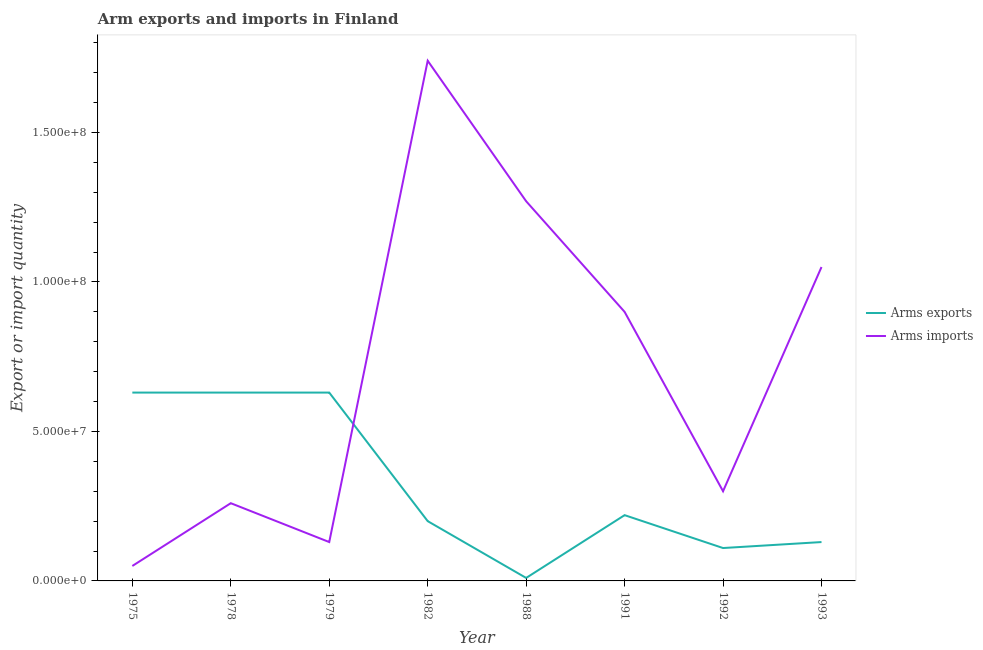How many different coloured lines are there?
Your answer should be very brief. 2. Does the line corresponding to arms exports intersect with the line corresponding to arms imports?
Make the answer very short. Yes. Is the number of lines equal to the number of legend labels?
Make the answer very short. Yes. What is the arms imports in 1979?
Your answer should be very brief. 1.30e+07. Across all years, what is the maximum arms imports?
Ensure brevity in your answer.  1.74e+08. Across all years, what is the minimum arms imports?
Provide a succinct answer. 5.00e+06. In which year was the arms imports maximum?
Keep it short and to the point. 1982. In which year was the arms exports minimum?
Make the answer very short. 1988. What is the total arms imports in the graph?
Keep it short and to the point. 5.70e+08. What is the difference between the arms imports in 1975 and that in 1978?
Offer a terse response. -2.10e+07. What is the difference between the arms exports in 1988 and the arms imports in 1978?
Provide a succinct answer. -2.50e+07. What is the average arms imports per year?
Your answer should be compact. 7.12e+07. In the year 1988, what is the difference between the arms exports and arms imports?
Provide a succinct answer. -1.26e+08. In how many years, is the arms imports greater than 70000000?
Keep it short and to the point. 4. What is the difference between the highest and the second highest arms imports?
Provide a short and direct response. 4.70e+07. What is the difference between the highest and the lowest arms imports?
Provide a short and direct response. 1.69e+08. In how many years, is the arms imports greater than the average arms imports taken over all years?
Provide a succinct answer. 4. Is the sum of the arms exports in 1979 and 1988 greater than the maximum arms imports across all years?
Provide a succinct answer. No. Does the arms imports monotonically increase over the years?
Keep it short and to the point. No. Is the arms exports strictly greater than the arms imports over the years?
Provide a succinct answer. No. Is the arms exports strictly less than the arms imports over the years?
Offer a terse response. No. How many lines are there?
Offer a very short reply. 2. How many years are there in the graph?
Offer a very short reply. 8. What is the difference between two consecutive major ticks on the Y-axis?
Your answer should be very brief. 5.00e+07. Are the values on the major ticks of Y-axis written in scientific E-notation?
Offer a very short reply. Yes. Does the graph contain grids?
Provide a short and direct response. No. How many legend labels are there?
Ensure brevity in your answer.  2. How are the legend labels stacked?
Offer a very short reply. Vertical. What is the title of the graph?
Offer a terse response. Arm exports and imports in Finland. Does "Pregnant women" appear as one of the legend labels in the graph?
Make the answer very short. No. What is the label or title of the X-axis?
Make the answer very short. Year. What is the label or title of the Y-axis?
Give a very brief answer. Export or import quantity. What is the Export or import quantity in Arms exports in 1975?
Provide a short and direct response. 6.30e+07. What is the Export or import quantity in Arms imports in 1975?
Make the answer very short. 5.00e+06. What is the Export or import quantity in Arms exports in 1978?
Provide a short and direct response. 6.30e+07. What is the Export or import quantity of Arms imports in 1978?
Offer a terse response. 2.60e+07. What is the Export or import quantity of Arms exports in 1979?
Offer a terse response. 6.30e+07. What is the Export or import quantity of Arms imports in 1979?
Offer a terse response. 1.30e+07. What is the Export or import quantity of Arms imports in 1982?
Ensure brevity in your answer.  1.74e+08. What is the Export or import quantity of Arms exports in 1988?
Make the answer very short. 1.00e+06. What is the Export or import quantity of Arms imports in 1988?
Provide a short and direct response. 1.27e+08. What is the Export or import quantity in Arms exports in 1991?
Provide a short and direct response. 2.20e+07. What is the Export or import quantity in Arms imports in 1991?
Give a very brief answer. 9.00e+07. What is the Export or import quantity of Arms exports in 1992?
Keep it short and to the point. 1.10e+07. What is the Export or import quantity of Arms imports in 1992?
Your answer should be compact. 3.00e+07. What is the Export or import quantity in Arms exports in 1993?
Your response must be concise. 1.30e+07. What is the Export or import quantity of Arms imports in 1993?
Your answer should be compact. 1.05e+08. Across all years, what is the maximum Export or import quantity in Arms exports?
Your answer should be compact. 6.30e+07. Across all years, what is the maximum Export or import quantity in Arms imports?
Offer a terse response. 1.74e+08. Across all years, what is the minimum Export or import quantity in Arms exports?
Give a very brief answer. 1.00e+06. Across all years, what is the minimum Export or import quantity in Arms imports?
Your answer should be compact. 5.00e+06. What is the total Export or import quantity in Arms exports in the graph?
Your answer should be very brief. 2.56e+08. What is the total Export or import quantity in Arms imports in the graph?
Give a very brief answer. 5.70e+08. What is the difference between the Export or import quantity of Arms exports in 1975 and that in 1978?
Ensure brevity in your answer.  0. What is the difference between the Export or import quantity of Arms imports in 1975 and that in 1978?
Offer a terse response. -2.10e+07. What is the difference between the Export or import quantity in Arms imports in 1975 and that in 1979?
Provide a succinct answer. -8.00e+06. What is the difference between the Export or import quantity in Arms exports in 1975 and that in 1982?
Give a very brief answer. 4.30e+07. What is the difference between the Export or import quantity in Arms imports in 1975 and that in 1982?
Keep it short and to the point. -1.69e+08. What is the difference between the Export or import quantity in Arms exports in 1975 and that in 1988?
Ensure brevity in your answer.  6.20e+07. What is the difference between the Export or import quantity in Arms imports in 1975 and that in 1988?
Ensure brevity in your answer.  -1.22e+08. What is the difference between the Export or import quantity in Arms exports in 1975 and that in 1991?
Give a very brief answer. 4.10e+07. What is the difference between the Export or import quantity in Arms imports in 1975 and that in 1991?
Ensure brevity in your answer.  -8.50e+07. What is the difference between the Export or import quantity of Arms exports in 1975 and that in 1992?
Keep it short and to the point. 5.20e+07. What is the difference between the Export or import quantity of Arms imports in 1975 and that in 1992?
Make the answer very short. -2.50e+07. What is the difference between the Export or import quantity in Arms exports in 1975 and that in 1993?
Keep it short and to the point. 5.00e+07. What is the difference between the Export or import quantity in Arms imports in 1975 and that in 1993?
Keep it short and to the point. -1.00e+08. What is the difference between the Export or import quantity of Arms exports in 1978 and that in 1979?
Make the answer very short. 0. What is the difference between the Export or import quantity of Arms imports in 1978 and that in 1979?
Make the answer very short. 1.30e+07. What is the difference between the Export or import quantity in Arms exports in 1978 and that in 1982?
Your answer should be compact. 4.30e+07. What is the difference between the Export or import quantity in Arms imports in 1978 and that in 1982?
Offer a very short reply. -1.48e+08. What is the difference between the Export or import quantity of Arms exports in 1978 and that in 1988?
Your answer should be very brief. 6.20e+07. What is the difference between the Export or import quantity in Arms imports in 1978 and that in 1988?
Keep it short and to the point. -1.01e+08. What is the difference between the Export or import quantity in Arms exports in 1978 and that in 1991?
Make the answer very short. 4.10e+07. What is the difference between the Export or import quantity of Arms imports in 1978 and that in 1991?
Provide a succinct answer. -6.40e+07. What is the difference between the Export or import quantity of Arms exports in 1978 and that in 1992?
Make the answer very short. 5.20e+07. What is the difference between the Export or import quantity in Arms imports in 1978 and that in 1993?
Your response must be concise. -7.90e+07. What is the difference between the Export or import quantity in Arms exports in 1979 and that in 1982?
Provide a short and direct response. 4.30e+07. What is the difference between the Export or import quantity of Arms imports in 1979 and that in 1982?
Ensure brevity in your answer.  -1.61e+08. What is the difference between the Export or import quantity of Arms exports in 1979 and that in 1988?
Keep it short and to the point. 6.20e+07. What is the difference between the Export or import quantity of Arms imports in 1979 and that in 1988?
Offer a terse response. -1.14e+08. What is the difference between the Export or import quantity of Arms exports in 1979 and that in 1991?
Provide a short and direct response. 4.10e+07. What is the difference between the Export or import quantity of Arms imports in 1979 and that in 1991?
Keep it short and to the point. -7.70e+07. What is the difference between the Export or import quantity of Arms exports in 1979 and that in 1992?
Provide a succinct answer. 5.20e+07. What is the difference between the Export or import quantity in Arms imports in 1979 and that in 1992?
Provide a succinct answer. -1.70e+07. What is the difference between the Export or import quantity of Arms imports in 1979 and that in 1993?
Make the answer very short. -9.20e+07. What is the difference between the Export or import quantity of Arms exports in 1982 and that in 1988?
Ensure brevity in your answer.  1.90e+07. What is the difference between the Export or import quantity of Arms imports in 1982 and that in 1988?
Make the answer very short. 4.70e+07. What is the difference between the Export or import quantity of Arms imports in 1982 and that in 1991?
Keep it short and to the point. 8.40e+07. What is the difference between the Export or import quantity of Arms exports in 1982 and that in 1992?
Provide a succinct answer. 9.00e+06. What is the difference between the Export or import quantity of Arms imports in 1982 and that in 1992?
Give a very brief answer. 1.44e+08. What is the difference between the Export or import quantity in Arms imports in 1982 and that in 1993?
Ensure brevity in your answer.  6.90e+07. What is the difference between the Export or import quantity in Arms exports in 1988 and that in 1991?
Keep it short and to the point. -2.10e+07. What is the difference between the Export or import quantity of Arms imports in 1988 and that in 1991?
Provide a short and direct response. 3.70e+07. What is the difference between the Export or import quantity of Arms exports in 1988 and that in 1992?
Ensure brevity in your answer.  -1.00e+07. What is the difference between the Export or import quantity in Arms imports in 1988 and that in 1992?
Offer a very short reply. 9.70e+07. What is the difference between the Export or import quantity in Arms exports in 1988 and that in 1993?
Your answer should be very brief. -1.20e+07. What is the difference between the Export or import quantity of Arms imports in 1988 and that in 1993?
Keep it short and to the point. 2.20e+07. What is the difference between the Export or import quantity in Arms exports in 1991 and that in 1992?
Provide a succinct answer. 1.10e+07. What is the difference between the Export or import quantity of Arms imports in 1991 and that in 1992?
Keep it short and to the point. 6.00e+07. What is the difference between the Export or import quantity of Arms exports in 1991 and that in 1993?
Offer a very short reply. 9.00e+06. What is the difference between the Export or import quantity of Arms imports in 1991 and that in 1993?
Your answer should be compact. -1.50e+07. What is the difference between the Export or import quantity in Arms exports in 1992 and that in 1993?
Ensure brevity in your answer.  -2.00e+06. What is the difference between the Export or import quantity of Arms imports in 1992 and that in 1993?
Make the answer very short. -7.50e+07. What is the difference between the Export or import quantity in Arms exports in 1975 and the Export or import quantity in Arms imports in 1978?
Give a very brief answer. 3.70e+07. What is the difference between the Export or import quantity in Arms exports in 1975 and the Export or import quantity in Arms imports in 1979?
Give a very brief answer. 5.00e+07. What is the difference between the Export or import quantity of Arms exports in 1975 and the Export or import quantity of Arms imports in 1982?
Ensure brevity in your answer.  -1.11e+08. What is the difference between the Export or import quantity in Arms exports in 1975 and the Export or import quantity in Arms imports in 1988?
Give a very brief answer. -6.40e+07. What is the difference between the Export or import quantity in Arms exports in 1975 and the Export or import quantity in Arms imports in 1991?
Ensure brevity in your answer.  -2.70e+07. What is the difference between the Export or import quantity of Arms exports in 1975 and the Export or import quantity of Arms imports in 1992?
Provide a succinct answer. 3.30e+07. What is the difference between the Export or import quantity in Arms exports in 1975 and the Export or import quantity in Arms imports in 1993?
Ensure brevity in your answer.  -4.20e+07. What is the difference between the Export or import quantity of Arms exports in 1978 and the Export or import quantity of Arms imports in 1979?
Offer a terse response. 5.00e+07. What is the difference between the Export or import quantity in Arms exports in 1978 and the Export or import quantity in Arms imports in 1982?
Your answer should be very brief. -1.11e+08. What is the difference between the Export or import quantity of Arms exports in 1978 and the Export or import quantity of Arms imports in 1988?
Offer a very short reply. -6.40e+07. What is the difference between the Export or import quantity in Arms exports in 1978 and the Export or import quantity in Arms imports in 1991?
Give a very brief answer. -2.70e+07. What is the difference between the Export or import quantity in Arms exports in 1978 and the Export or import quantity in Arms imports in 1992?
Give a very brief answer. 3.30e+07. What is the difference between the Export or import quantity of Arms exports in 1978 and the Export or import quantity of Arms imports in 1993?
Provide a succinct answer. -4.20e+07. What is the difference between the Export or import quantity of Arms exports in 1979 and the Export or import quantity of Arms imports in 1982?
Give a very brief answer. -1.11e+08. What is the difference between the Export or import quantity in Arms exports in 1979 and the Export or import quantity in Arms imports in 1988?
Your answer should be compact. -6.40e+07. What is the difference between the Export or import quantity of Arms exports in 1979 and the Export or import quantity of Arms imports in 1991?
Your response must be concise. -2.70e+07. What is the difference between the Export or import quantity in Arms exports in 1979 and the Export or import quantity in Arms imports in 1992?
Keep it short and to the point. 3.30e+07. What is the difference between the Export or import quantity of Arms exports in 1979 and the Export or import quantity of Arms imports in 1993?
Provide a short and direct response. -4.20e+07. What is the difference between the Export or import quantity of Arms exports in 1982 and the Export or import quantity of Arms imports in 1988?
Keep it short and to the point. -1.07e+08. What is the difference between the Export or import quantity in Arms exports in 1982 and the Export or import quantity in Arms imports in 1991?
Offer a terse response. -7.00e+07. What is the difference between the Export or import quantity of Arms exports in 1982 and the Export or import quantity of Arms imports in 1992?
Ensure brevity in your answer.  -1.00e+07. What is the difference between the Export or import quantity of Arms exports in 1982 and the Export or import quantity of Arms imports in 1993?
Offer a very short reply. -8.50e+07. What is the difference between the Export or import quantity of Arms exports in 1988 and the Export or import quantity of Arms imports in 1991?
Make the answer very short. -8.90e+07. What is the difference between the Export or import quantity in Arms exports in 1988 and the Export or import quantity in Arms imports in 1992?
Keep it short and to the point. -2.90e+07. What is the difference between the Export or import quantity in Arms exports in 1988 and the Export or import quantity in Arms imports in 1993?
Ensure brevity in your answer.  -1.04e+08. What is the difference between the Export or import quantity in Arms exports in 1991 and the Export or import quantity in Arms imports in 1992?
Make the answer very short. -8.00e+06. What is the difference between the Export or import quantity of Arms exports in 1991 and the Export or import quantity of Arms imports in 1993?
Offer a terse response. -8.30e+07. What is the difference between the Export or import quantity in Arms exports in 1992 and the Export or import quantity in Arms imports in 1993?
Your answer should be compact. -9.40e+07. What is the average Export or import quantity in Arms exports per year?
Provide a short and direct response. 3.20e+07. What is the average Export or import quantity in Arms imports per year?
Your response must be concise. 7.12e+07. In the year 1975, what is the difference between the Export or import quantity of Arms exports and Export or import quantity of Arms imports?
Give a very brief answer. 5.80e+07. In the year 1978, what is the difference between the Export or import quantity of Arms exports and Export or import quantity of Arms imports?
Give a very brief answer. 3.70e+07. In the year 1982, what is the difference between the Export or import quantity in Arms exports and Export or import quantity in Arms imports?
Your answer should be very brief. -1.54e+08. In the year 1988, what is the difference between the Export or import quantity of Arms exports and Export or import quantity of Arms imports?
Provide a succinct answer. -1.26e+08. In the year 1991, what is the difference between the Export or import quantity in Arms exports and Export or import quantity in Arms imports?
Provide a short and direct response. -6.80e+07. In the year 1992, what is the difference between the Export or import quantity in Arms exports and Export or import quantity in Arms imports?
Provide a short and direct response. -1.90e+07. In the year 1993, what is the difference between the Export or import quantity in Arms exports and Export or import quantity in Arms imports?
Keep it short and to the point. -9.20e+07. What is the ratio of the Export or import quantity of Arms exports in 1975 to that in 1978?
Ensure brevity in your answer.  1. What is the ratio of the Export or import quantity of Arms imports in 1975 to that in 1978?
Provide a succinct answer. 0.19. What is the ratio of the Export or import quantity of Arms exports in 1975 to that in 1979?
Offer a very short reply. 1. What is the ratio of the Export or import quantity in Arms imports in 1975 to that in 1979?
Provide a succinct answer. 0.38. What is the ratio of the Export or import quantity of Arms exports in 1975 to that in 1982?
Give a very brief answer. 3.15. What is the ratio of the Export or import quantity of Arms imports in 1975 to that in 1982?
Offer a very short reply. 0.03. What is the ratio of the Export or import quantity in Arms exports in 1975 to that in 1988?
Offer a terse response. 63. What is the ratio of the Export or import quantity in Arms imports in 1975 to that in 1988?
Provide a short and direct response. 0.04. What is the ratio of the Export or import quantity in Arms exports in 1975 to that in 1991?
Offer a terse response. 2.86. What is the ratio of the Export or import quantity of Arms imports in 1975 to that in 1991?
Offer a very short reply. 0.06. What is the ratio of the Export or import quantity in Arms exports in 1975 to that in 1992?
Your answer should be compact. 5.73. What is the ratio of the Export or import quantity of Arms imports in 1975 to that in 1992?
Offer a very short reply. 0.17. What is the ratio of the Export or import quantity in Arms exports in 1975 to that in 1993?
Keep it short and to the point. 4.85. What is the ratio of the Export or import quantity of Arms imports in 1975 to that in 1993?
Provide a succinct answer. 0.05. What is the ratio of the Export or import quantity in Arms exports in 1978 to that in 1979?
Your answer should be very brief. 1. What is the ratio of the Export or import quantity of Arms imports in 1978 to that in 1979?
Make the answer very short. 2. What is the ratio of the Export or import quantity of Arms exports in 1978 to that in 1982?
Ensure brevity in your answer.  3.15. What is the ratio of the Export or import quantity of Arms imports in 1978 to that in 1982?
Your answer should be very brief. 0.15. What is the ratio of the Export or import quantity of Arms exports in 1978 to that in 1988?
Provide a succinct answer. 63. What is the ratio of the Export or import quantity in Arms imports in 1978 to that in 1988?
Offer a terse response. 0.2. What is the ratio of the Export or import quantity of Arms exports in 1978 to that in 1991?
Offer a terse response. 2.86. What is the ratio of the Export or import quantity in Arms imports in 1978 to that in 1991?
Provide a succinct answer. 0.29. What is the ratio of the Export or import quantity in Arms exports in 1978 to that in 1992?
Offer a terse response. 5.73. What is the ratio of the Export or import quantity of Arms imports in 1978 to that in 1992?
Make the answer very short. 0.87. What is the ratio of the Export or import quantity of Arms exports in 1978 to that in 1993?
Offer a very short reply. 4.85. What is the ratio of the Export or import quantity of Arms imports in 1978 to that in 1993?
Offer a very short reply. 0.25. What is the ratio of the Export or import quantity of Arms exports in 1979 to that in 1982?
Keep it short and to the point. 3.15. What is the ratio of the Export or import quantity of Arms imports in 1979 to that in 1982?
Offer a very short reply. 0.07. What is the ratio of the Export or import quantity of Arms imports in 1979 to that in 1988?
Keep it short and to the point. 0.1. What is the ratio of the Export or import quantity in Arms exports in 1979 to that in 1991?
Provide a succinct answer. 2.86. What is the ratio of the Export or import quantity of Arms imports in 1979 to that in 1991?
Offer a very short reply. 0.14. What is the ratio of the Export or import quantity in Arms exports in 1979 to that in 1992?
Ensure brevity in your answer.  5.73. What is the ratio of the Export or import quantity of Arms imports in 1979 to that in 1992?
Provide a succinct answer. 0.43. What is the ratio of the Export or import quantity in Arms exports in 1979 to that in 1993?
Offer a terse response. 4.85. What is the ratio of the Export or import quantity of Arms imports in 1979 to that in 1993?
Give a very brief answer. 0.12. What is the ratio of the Export or import quantity in Arms exports in 1982 to that in 1988?
Offer a terse response. 20. What is the ratio of the Export or import quantity in Arms imports in 1982 to that in 1988?
Ensure brevity in your answer.  1.37. What is the ratio of the Export or import quantity of Arms exports in 1982 to that in 1991?
Make the answer very short. 0.91. What is the ratio of the Export or import quantity in Arms imports in 1982 to that in 1991?
Make the answer very short. 1.93. What is the ratio of the Export or import quantity of Arms exports in 1982 to that in 1992?
Ensure brevity in your answer.  1.82. What is the ratio of the Export or import quantity in Arms imports in 1982 to that in 1992?
Your answer should be compact. 5.8. What is the ratio of the Export or import quantity of Arms exports in 1982 to that in 1993?
Offer a very short reply. 1.54. What is the ratio of the Export or import quantity of Arms imports in 1982 to that in 1993?
Provide a short and direct response. 1.66. What is the ratio of the Export or import quantity of Arms exports in 1988 to that in 1991?
Offer a very short reply. 0.05. What is the ratio of the Export or import quantity of Arms imports in 1988 to that in 1991?
Ensure brevity in your answer.  1.41. What is the ratio of the Export or import quantity in Arms exports in 1988 to that in 1992?
Ensure brevity in your answer.  0.09. What is the ratio of the Export or import quantity of Arms imports in 1988 to that in 1992?
Keep it short and to the point. 4.23. What is the ratio of the Export or import quantity of Arms exports in 1988 to that in 1993?
Offer a terse response. 0.08. What is the ratio of the Export or import quantity in Arms imports in 1988 to that in 1993?
Make the answer very short. 1.21. What is the ratio of the Export or import quantity in Arms exports in 1991 to that in 1993?
Offer a terse response. 1.69. What is the ratio of the Export or import quantity in Arms imports in 1991 to that in 1993?
Provide a succinct answer. 0.86. What is the ratio of the Export or import quantity of Arms exports in 1992 to that in 1993?
Keep it short and to the point. 0.85. What is the ratio of the Export or import quantity in Arms imports in 1992 to that in 1993?
Your answer should be compact. 0.29. What is the difference between the highest and the second highest Export or import quantity in Arms imports?
Make the answer very short. 4.70e+07. What is the difference between the highest and the lowest Export or import quantity of Arms exports?
Ensure brevity in your answer.  6.20e+07. What is the difference between the highest and the lowest Export or import quantity of Arms imports?
Offer a terse response. 1.69e+08. 